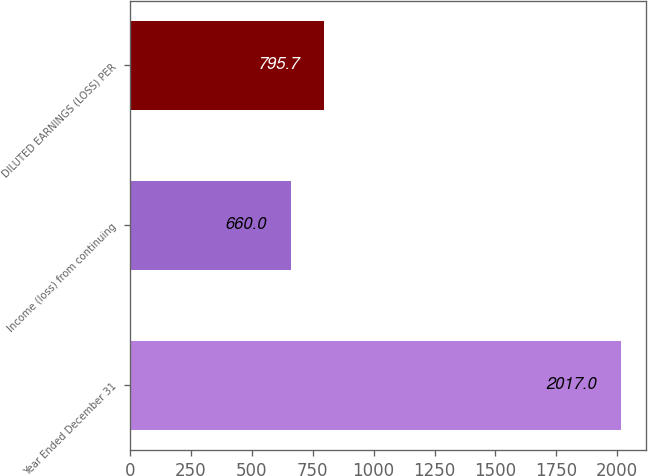Convert chart. <chart><loc_0><loc_0><loc_500><loc_500><bar_chart><fcel>Year Ended December 31<fcel>Income (loss) from continuing<fcel>DILUTED EARNINGS (LOSS) PER<nl><fcel>2017<fcel>660<fcel>795.7<nl></chart> 